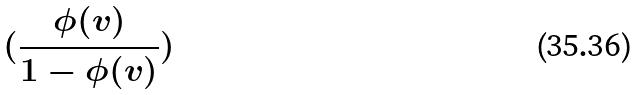<formula> <loc_0><loc_0><loc_500><loc_500>( \frac { \phi ( v ) } { 1 - \phi ( v ) } )</formula> 